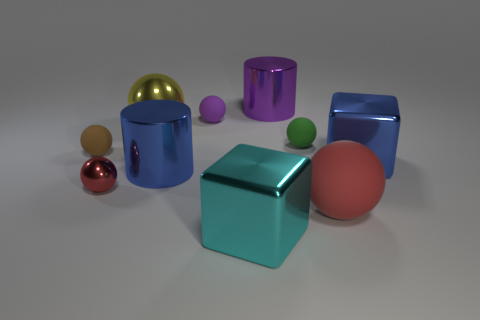Subtract all brown balls. How many balls are left? 5 Subtract all small red spheres. How many spheres are left? 5 Subtract 3 spheres. How many spheres are left? 3 Subtract all brown balls. Subtract all green cylinders. How many balls are left? 5 Subtract all blocks. How many objects are left? 8 Add 5 big yellow spheres. How many big yellow spheres exist? 6 Subtract 1 purple cylinders. How many objects are left? 9 Subtract all red metal balls. Subtract all metal things. How many objects are left? 3 Add 2 big blocks. How many big blocks are left? 4 